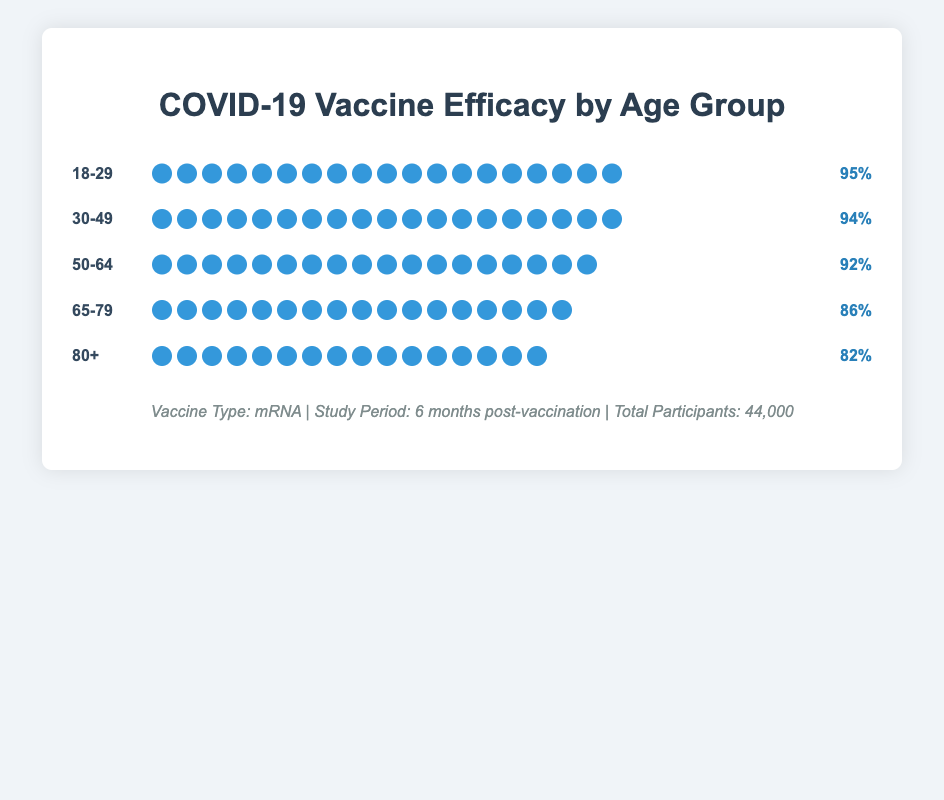What is the efficacy rate for the 50-64 age group? The efficacy rate for the 50-64 age group is listed at the end of its row, next to the icons.
Answer: 92% How many icons are shown for the 65-79 age group? The number of icons is represented by the "icon_count" field in the data, which controls how many blue circle icons are displayed for each age group in the figure. For the 65-79 age group, there are 17 icons shown.
Answer: 17 Which age group has the highest efficacy rate, and what is it? To determine the highest efficacy rate, compare the efficacy percentages given for each age group. The 18-29 age group has the highest efficacy rate at 95%.
Answer: 18-29, 95% By how much does the efficacy rate drop when comparing the 30-49 age group to the 80+ age group? Subtract the efficacy rate of the 80+ age group (82%) from the efficacy rate of the 30-49 age group (94%) to find the difference.
Answer: 12% If you sum the efficacy rates of the 18-29 and 65-79 age groups, what do you get? Add the efficacy rates of the 18-29 (95%) and 65-79 (86%) age groups together. 95 + 86 = 181
Answer: 181 For which age group is the efficacy rate below 90%? Check the efficacy rates for all age groups and identify those below 90%. The 65-79 (86%) and 80+ (82%) age groups have efficacy rates below 90%.
Answer: 65-79, 80+ How does the efficacy rate for the 50-64 age group compare to the 30-49 age group? Compare the efficacy rates of 50-64 (92%) and 30-49 (94%) age groups. 94 is greater than 92.
Answer: The 30-49 age group has a higher efficacy rate Calculate the average efficacy rate across all age groups. Add all efficacy rates together and divide by the number of age groups. (95 + 94 + 92 + 86 + 82) / 5 = 449 / 5 = 89.8
Answer: 89.8 What is the visual indicator used to represent the efficacy rates, and how does it vary? The efficacy rates are represented by blue circle icons, which vary in number for each age group in proportion to their efficacy rate.
Answer: Blue circle icons, varying counts 